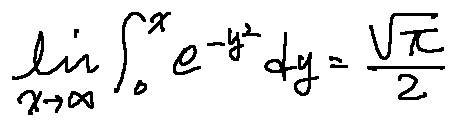<formula> <loc_0><loc_0><loc_500><loc_500>\lim \lim i t s _ { x \rightarrow \infty } \int \lim i t s _ { 0 } ^ { x } e ^ { - y ^ { 2 } } d y = \frac { \sqrt { \pi } } { 2 }</formula> 